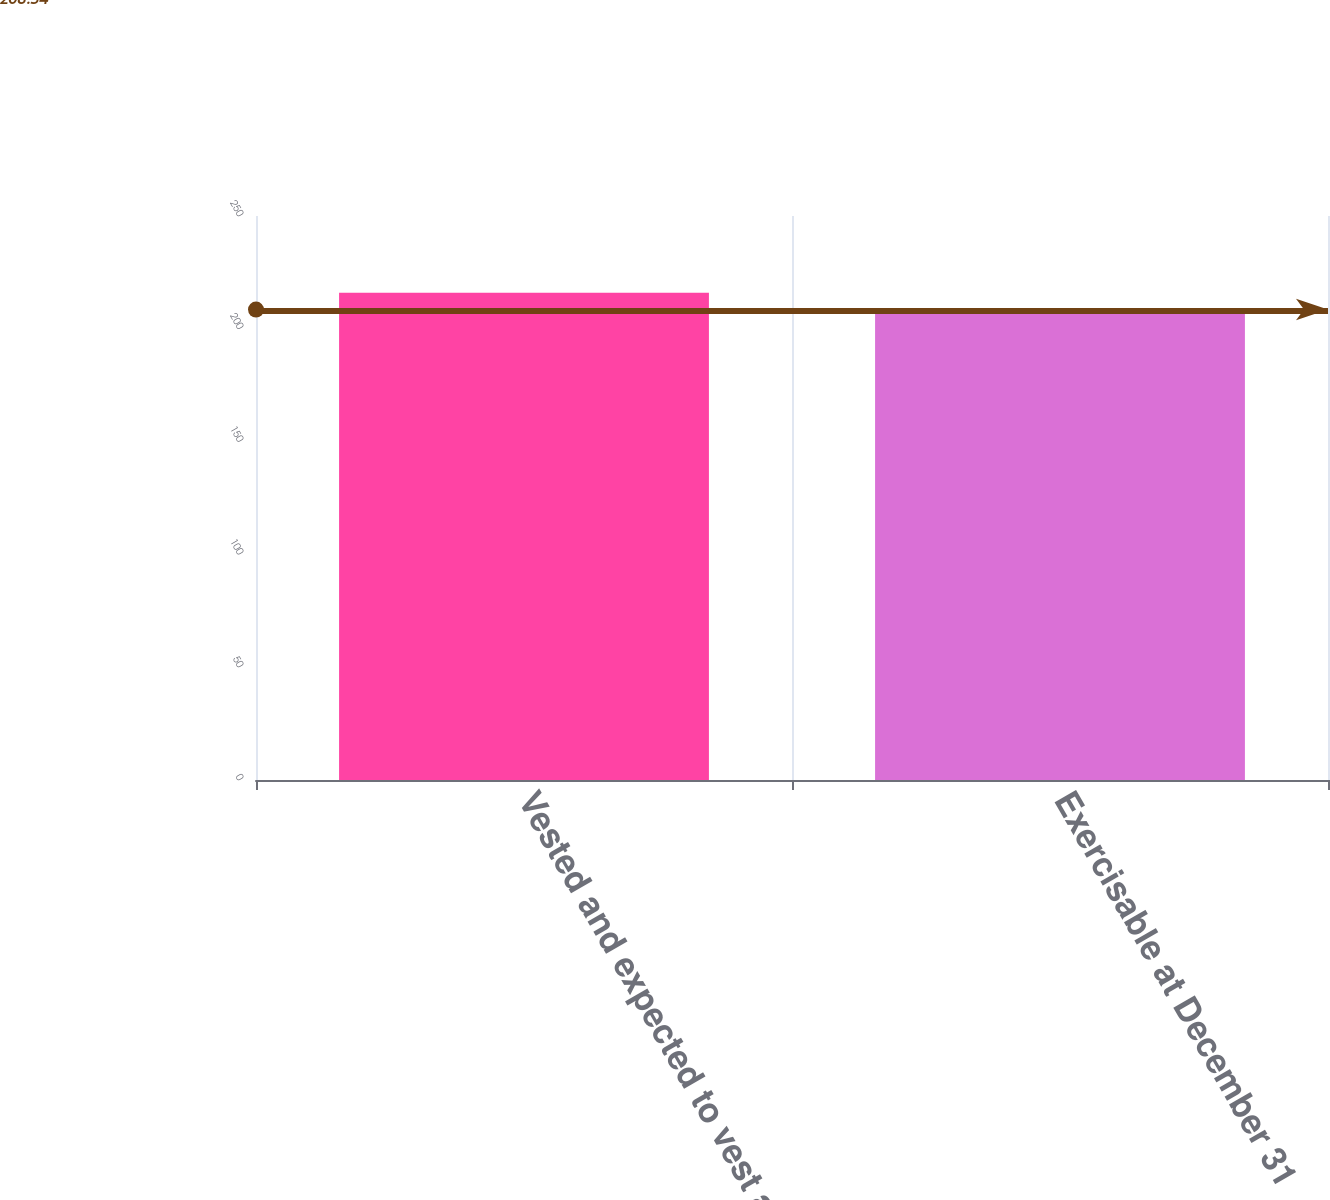Convert chart. <chart><loc_0><loc_0><loc_500><loc_500><bar_chart><fcel>Vested and expected to vest at<fcel>Exercisable at December 31<nl><fcel>216<fcel>207<nl></chart> 